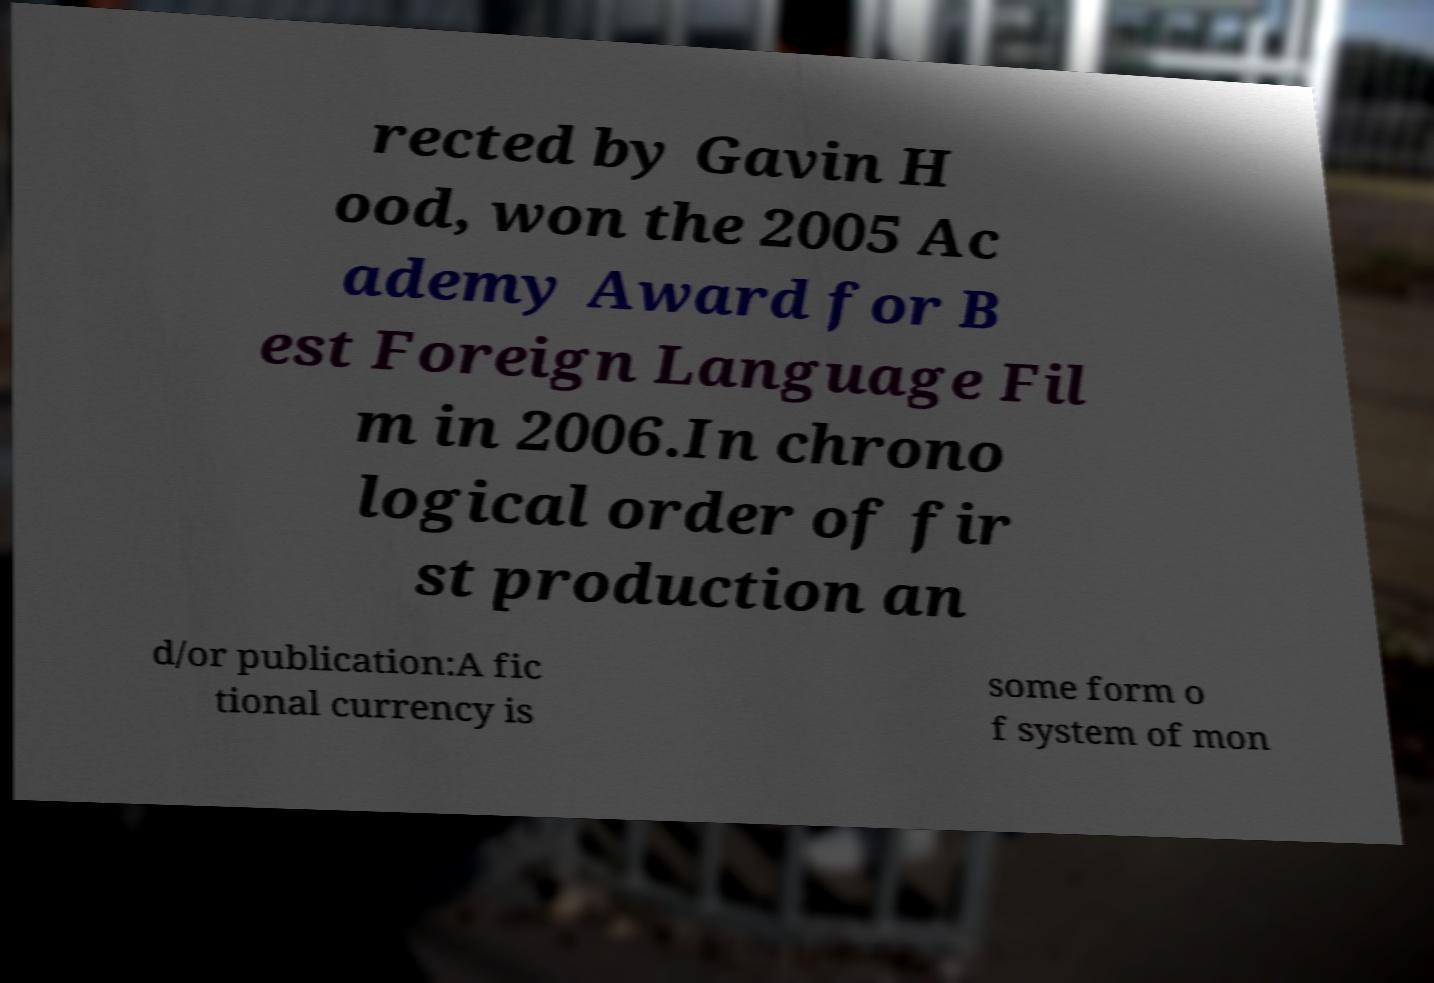Can you accurately transcribe the text from the provided image for me? rected by Gavin H ood, won the 2005 Ac ademy Award for B est Foreign Language Fil m in 2006.In chrono logical order of fir st production an d/or publication:A fic tional currency is some form o f system of mon 